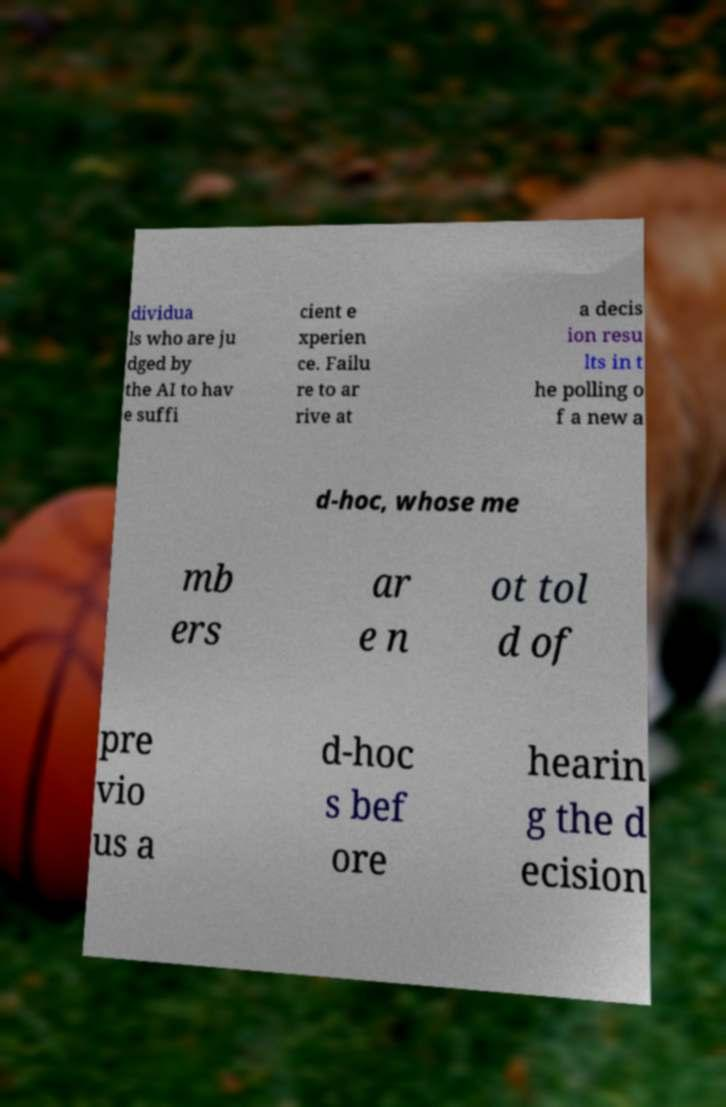Can you read and provide the text displayed in the image?This photo seems to have some interesting text. Can you extract and type it out for me? dividua ls who are ju dged by the AI to hav e suffi cient e xperien ce. Failu re to ar rive at a decis ion resu lts in t he polling o f a new a d-hoc, whose me mb ers ar e n ot tol d of pre vio us a d-hoc s bef ore hearin g the d ecision 